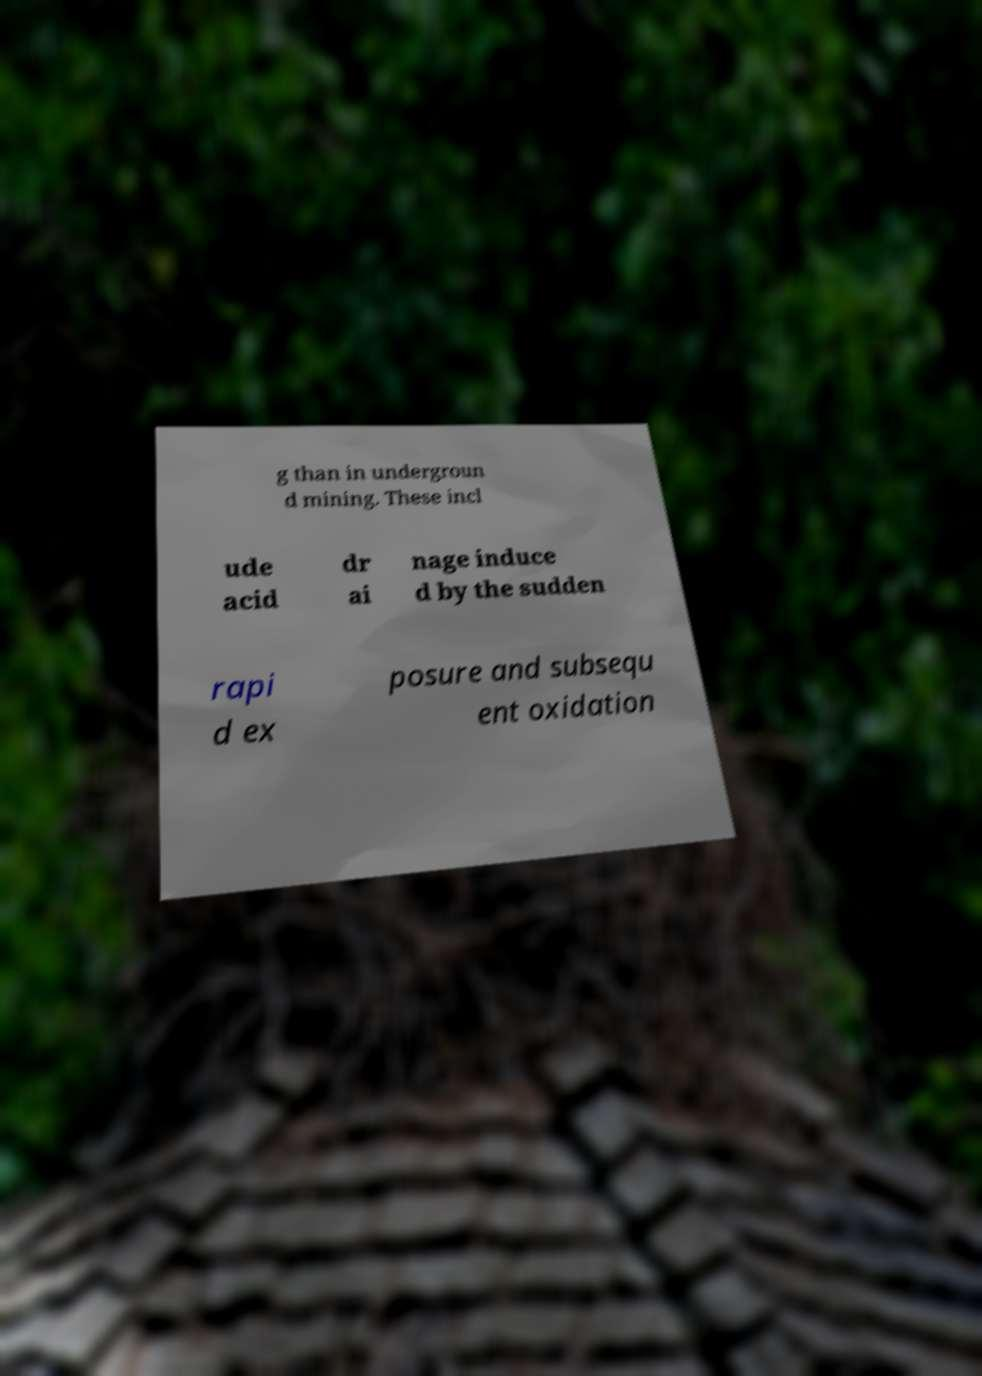For documentation purposes, I need the text within this image transcribed. Could you provide that? g than in undergroun d mining. These incl ude acid dr ai nage induce d by the sudden rapi d ex posure and subsequ ent oxidation 